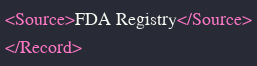Convert code to text. <code><loc_0><loc_0><loc_500><loc_500><_XML_><Source>FDA Registry</Source>
</Record>
</code> 